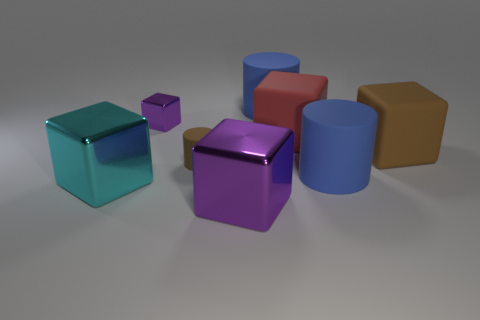Add 1 big green rubber objects. How many objects exist? 9 Subtract all large matte blocks. How many blocks are left? 3 Subtract all brown cylinders. How many cylinders are left? 2 Subtract 1 cylinders. How many cylinders are left? 2 Subtract all yellow cubes. Subtract all gray cylinders. How many cubes are left? 5 Subtract all brown blocks. How many purple cylinders are left? 0 Subtract all big brown matte objects. Subtract all tiny purple objects. How many objects are left? 6 Add 1 metallic blocks. How many metallic blocks are left? 4 Add 7 small brown matte cylinders. How many small brown matte cylinders exist? 8 Subtract 2 blue cylinders. How many objects are left? 6 